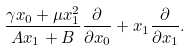<formula> <loc_0><loc_0><loc_500><loc_500>\frac { \gamma x _ { 0 } + \mu x _ { 1 } ^ { 2 } } { A x _ { 1 } + B } \frac { \partial } { \partial x _ { 0 } } + x _ { 1 } \frac { \partial } { \partial x _ { 1 } } .</formula> 